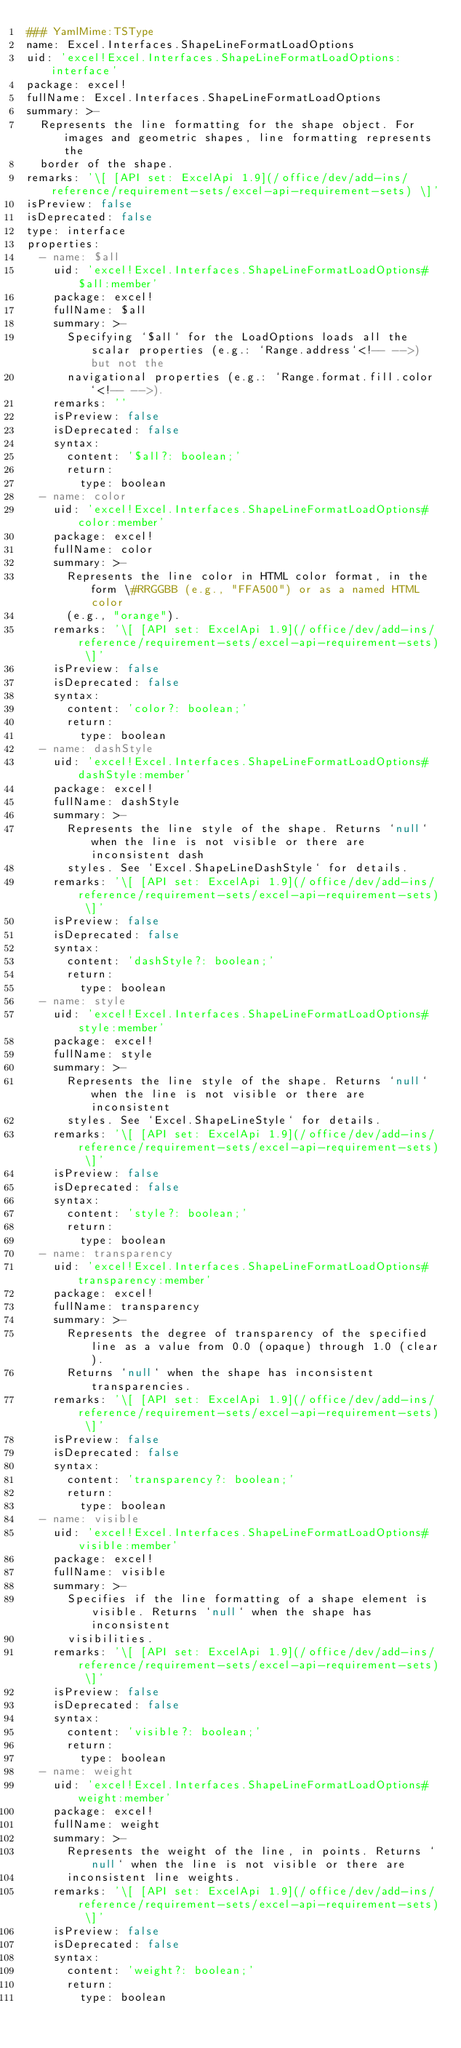Convert code to text. <code><loc_0><loc_0><loc_500><loc_500><_YAML_>### YamlMime:TSType
name: Excel.Interfaces.ShapeLineFormatLoadOptions
uid: 'excel!Excel.Interfaces.ShapeLineFormatLoadOptions:interface'
package: excel!
fullName: Excel.Interfaces.ShapeLineFormatLoadOptions
summary: >-
  Represents the line formatting for the shape object. For images and geometric shapes, line formatting represents the
  border of the shape.
remarks: '\[ [API set: ExcelApi 1.9](/office/dev/add-ins/reference/requirement-sets/excel-api-requirement-sets) \]'
isPreview: false
isDeprecated: false
type: interface
properties:
  - name: $all
    uid: 'excel!Excel.Interfaces.ShapeLineFormatLoadOptions#$all:member'
    package: excel!
    fullName: $all
    summary: >-
      Specifying `$all` for the LoadOptions loads all the scalar properties (e.g.: `Range.address`<!-- -->) but not the
      navigational properties (e.g.: `Range.format.fill.color`<!-- -->).
    remarks: ''
    isPreview: false
    isDeprecated: false
    syntax:
      content: '$all?: boolean;'
      return:
        type: boolean
  - name: color
    uid: 'excel!Excel.Interfaces.ShapeLineFormatLoadOptions#color:member'
    package: excel!
    fullName: color
    summary: >-
      Represents the line color in HTML color format, in the form \#RRGGBB (e.g., "FFA500") or as a named HTML color
      (e.g., "orange").
    remarks: '\[ [API set: ExcelApi 1.9](/office/dev/add-ins/reference/requirement-sets/excel-api-requirement-sets) \]'
    isPreview: false
    isDeprecated: false
    syntax:
      content: 'color?: boolean;'
      return:
        type: boolean
  - name: dashStyle
    uid: 'excel!Excel.Interfaces.ShapeLineFormatLoadOptions#dashStyle:member'
    package: excel!
    fullName: dashStyle
    summary: >-
      Represents the line style of the shape. Returns `null` when the line is not visible or there are inconsistent dash
      styles. See `Excel.ShapeLineDashStyle` for details.
    remarks: '\[ [API set: ExcelApi 1.9](/office/dev/add-ins/reference/requirement-sets/excel-api-requirement-sets) \]'
    isPreview: false
    isDeprecated: false
    syntax:
      content: 'dashStyle?: boolean;'
      return:
        type: boolean
  - name: style
    uid: 'excel!Excel.Interfaces.ShapeLineFormatLoadOptions#style:member'
    package: excel!
    fullName: style
    summary: >-
      Represents the line style of the shape. Returns `null` when the line is not visible or there are inconsistent
      styles. See `Excel.ShapeLineStyle` for details.
    remarks: '\[ [API set: ExcelApi 1.9](/office/dev/add-ins/reference/requirement-sets/excel-api-requirement-sets) \]'
    isPreview: false
    isDeprecated: false
    syntax:
      content: 'style?: boolean;'
      return:
        type: boolean
  - name: transparency
    uid: 'excel!Excel.Interfaces.ShapeLineFormatLoadOptions#transparency:member'
    package: excel!
    fullName: transparency
    summary: >-
      Represents the degree of transparency of the specified line as a value from 0.0 (opaque) through 1.0 (clear).
      Returns `null` when the shape has inconsistent transparencies.
    remarks: '\[ [API set: ExcelApi 1.9](/office/dev/add-ins/reference/requirement-sets/excel-api-requirement-sets) \]'
    isPreview: false
    isDeprecated: false
    syntax:
      content: 'transparency?: boolean;'
      return:
        type: boolean
  - name: visible
    uid: 'excel!Excel.Interfaces.ShapeLineFormatLoadOptions#visible:member'
    package: excel!
    fullName: visible
    summary: >-
      Specifies if the line formatting of a shape element is visible. Returns `null` when the shape has inconsistent
      visibilities.
    remarks: '\[ [API set: ExcelApi 1.9](/office/dev/add-ins/reference/requirement-sets/excel-api-requirement-sets) \]'
    isPreview: false
    isDeprecated: false
    syntax:
      content: 'visible?: boolean;'
      return:
        type: boolean
  - name: weight
    uid: 'excel!Excel.Interfaces.ShapeLineFormatLoadOptions#weight:member'
    package: excel!
    fullName: weight
    summary: >-
      Represents the weight of the line, in points. Returns `null` when the line is not visible or there are
      inconsistent line weights.
    remarks: '\[ [API set: ExcelApi 1.9](/office/dev/add-ins/reference/requirement-sets/excel-api-requirement-sets) \]'
    isPreview: false
    isDeprecated: false
    syntax:
      content: 'weight?: boolean;'
      return:
        type: boolean
</code> 